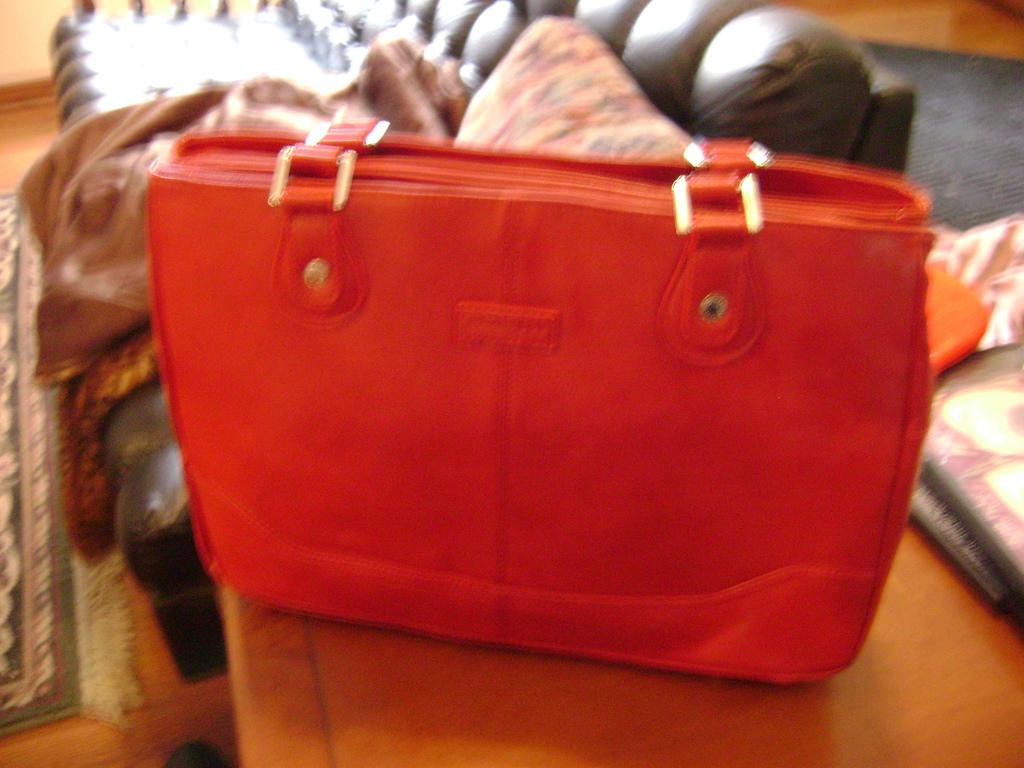Where was the image taken? The image was taken in a room. What can be seen on the table in the image? There is a red bag on a table in the image. What is visible behind the red bag? The background of the bag includes a sofa. What is on the sofa in the image? There is a pillow on the sofa in the image. What type of fabric is present in the background? There is a cloth in the background of the image. What news is being reported on the red bag in the image? There is no news being reported on the red bag in the image; it is simply a bag on a table. What unit of wealth is depicted on the red bag in the image? There is no depiction of wealth on the red bag in the image; it is just a red bag. 